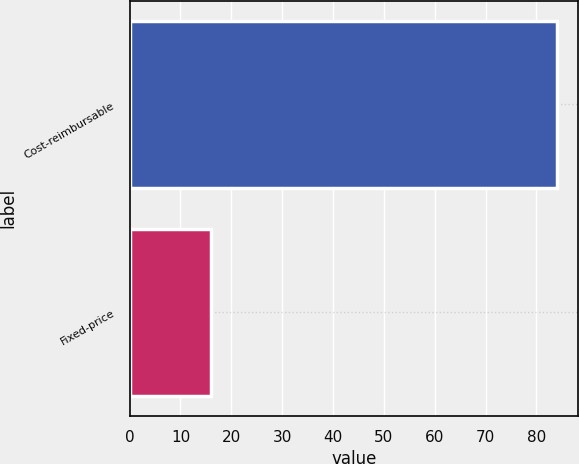Convert chart. <chart><loc_0><loc_0><loc_500><loc_500><bar_chart><fcel>Cost-reimbursable<fcel>Fixed-price<nl><fcel>84<fcel>16<nl></chart> 